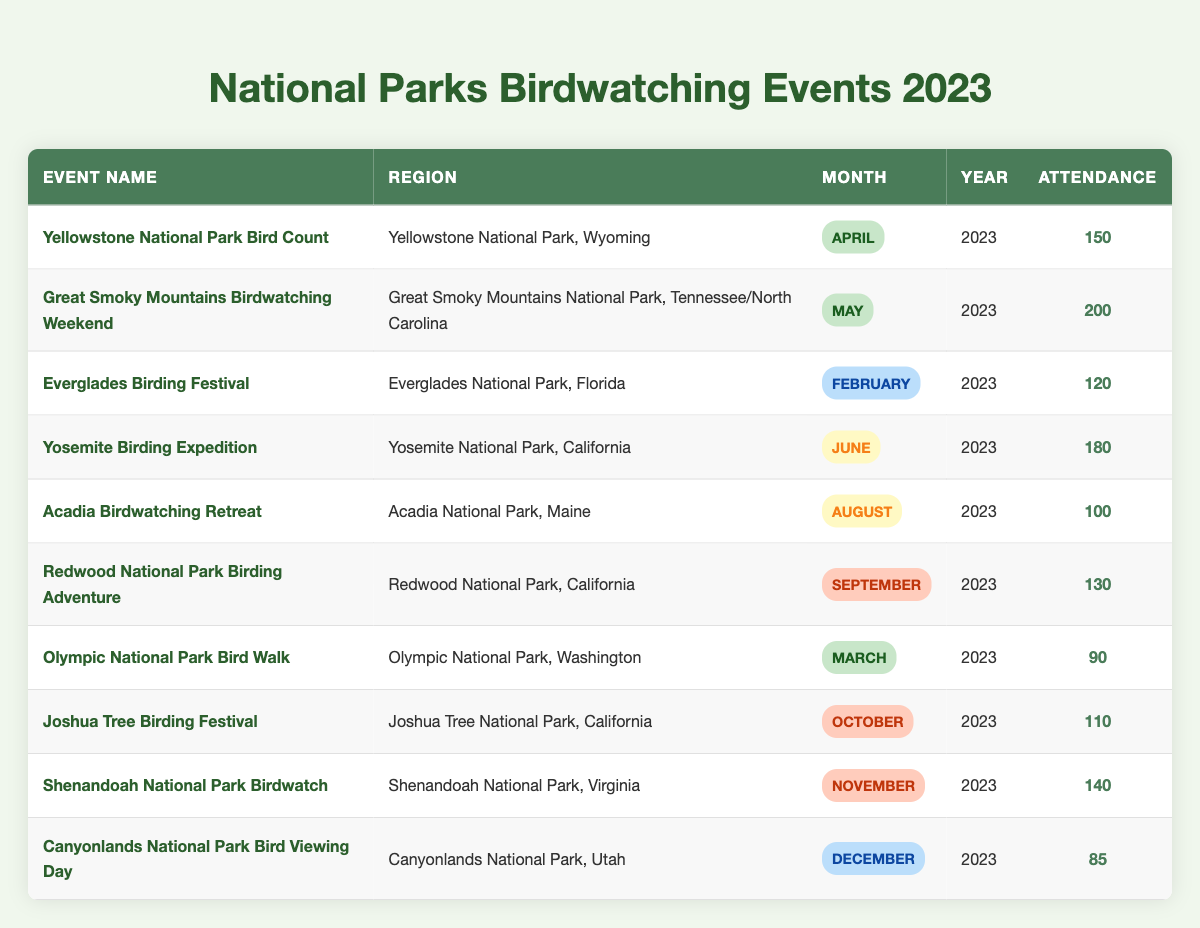What is the attendance at the Great Smoky Mountains Birdwatching Weekend? The table indicates that the attendance for this event is specifically mentioned as 200.
Answer: 200 Which birdwatching event had the highest attendance in 2023? By examining the attendance numbers in the table for each event, the Great Smoky Mountains Birdwatching Weekend has the highest attendance of 200.
Answer: Great Smoky Mountains Birdwatching Weekend How many birdwatching events are scheduled for the summer months? The summer months include June and August. Looking at the table, there are two events: the Yosemite Birding Expedition in June and the Acadia Birdwatching Retreat in August.
Answer: 2 Is there a birdwatching event in December? The table shows that there is a birdwatching event called Canyonlands National Park Bird Viewing Day scheduled for December 2023.
Answer: Yes What is the total attendance of the birdwatching events in fall months? The fall months include September, October, and November. Referring to the table: Redwood National Park Birding Adventure (130), Joshua Tree Birding Festival (110), and Shenandoah National Park Birdwatch (140). Adding these together gives 130 + 110 + 140 = 380.
Answer: 380 Which region had the least attendance for a birdwatching event, and what was that attendance? The table shows the attendance numbers for each region, and the lowest attendance is 85 for the Canyonlands National Park Bird Viewing Day. Therefore, the region with the least attendance is Canyonlands National Park, and the attendance is 85.
Answer: Canyonlands National Park, 85 What is the average attendance for birdwatching events across the entire year? To find the average attendance, first sum all attendance numbers: 150 + 200 + 120 + 180 + 100 + 130 + 90 + 110 + 140 + 85 = 1,275. Then divide this sum by the number of events (10), resulting in 1,275 / 10 = 127.5.
Answer: 127.5 How many birdwatching events were held in the spring? Spring includes the months of March, April, and May. The table lists the Olympic National Park Bird Walk (March), Yellowstone National Park Bird Count (April), and Great Smoky Mountains Birdwatching Weekend (May), totaling three events in the spring.
Answer: 3 